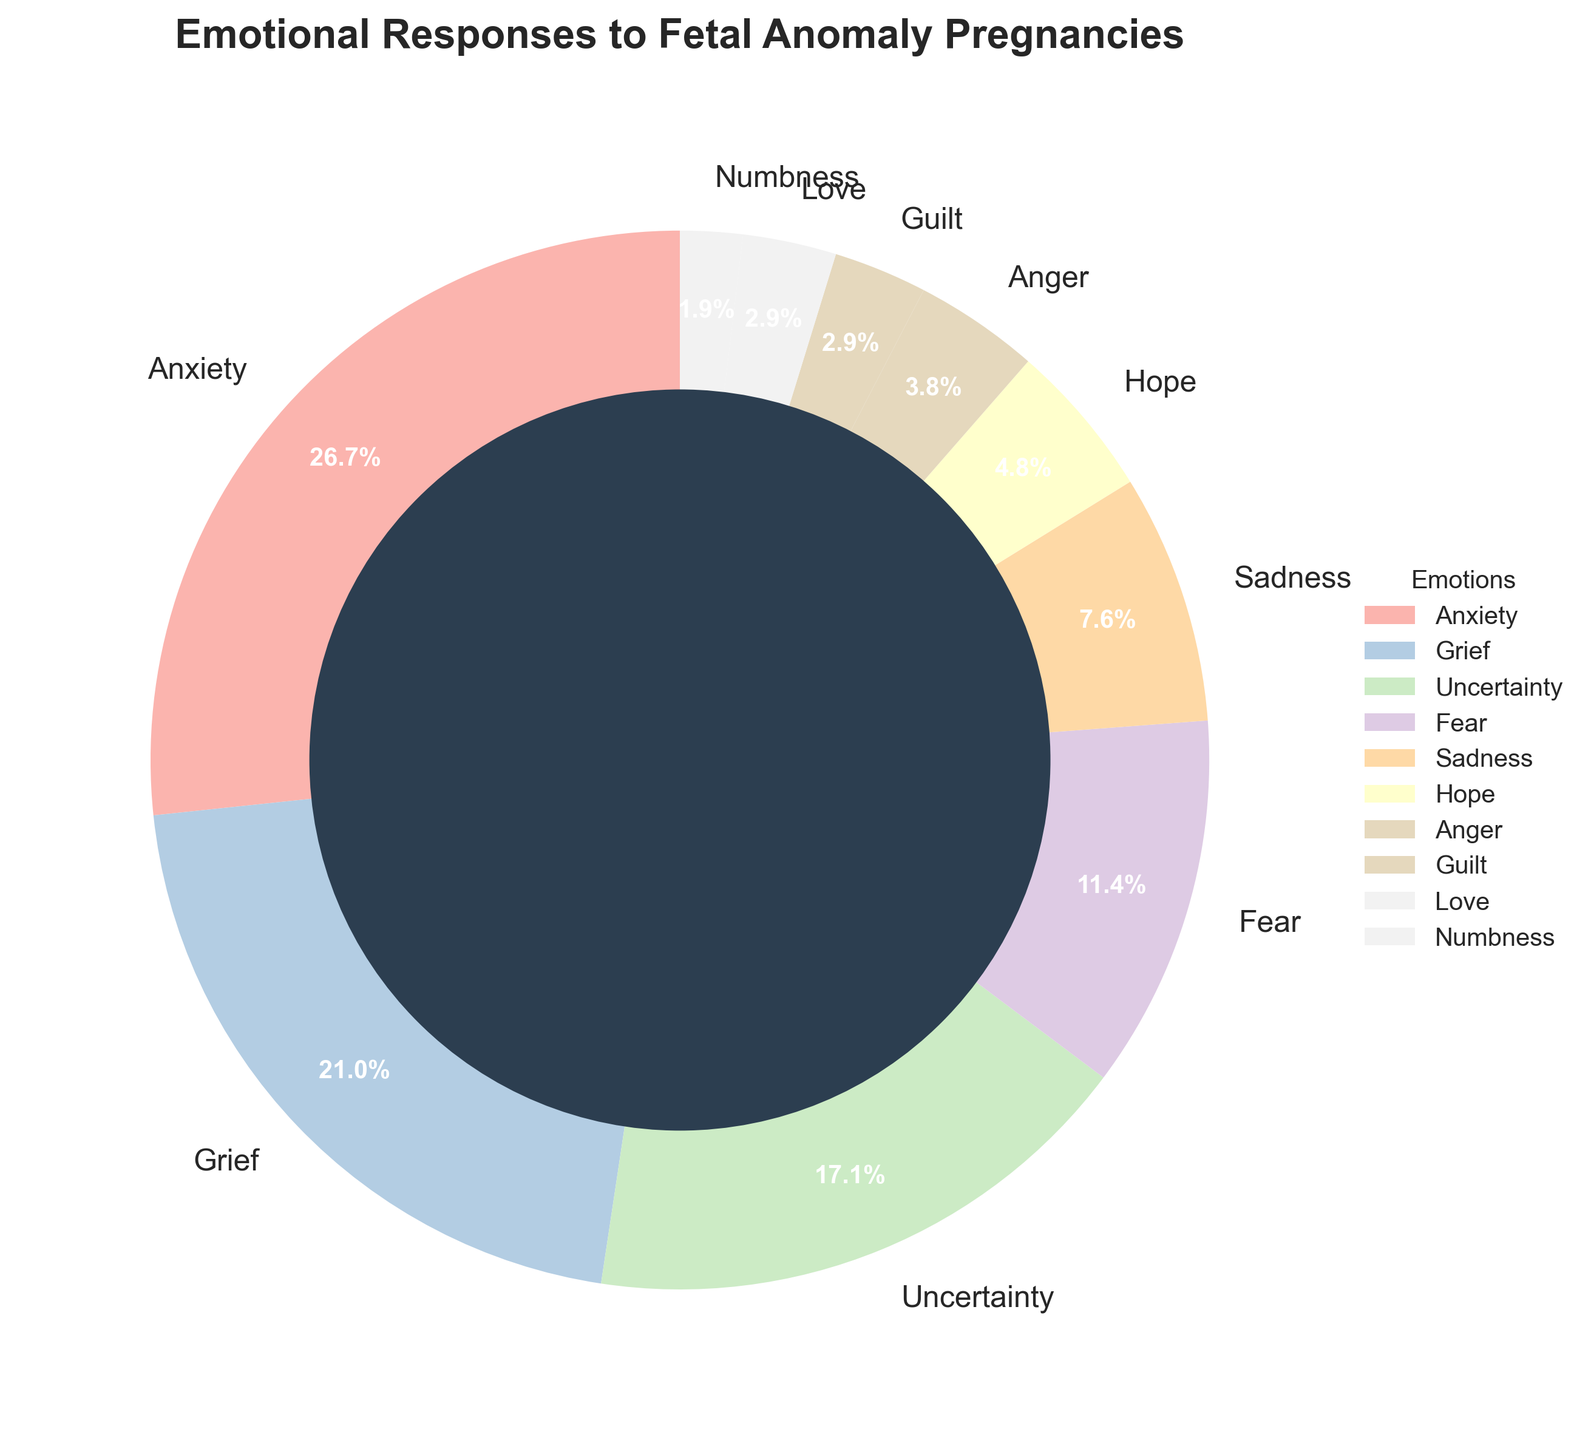What percentage of women reported anxiety? According to the figure, the pie chart segment labeled "Anxiety" shows 28%. Therefore, 28% of women reported anxiety.
Answer: 28% Which emotions combined make up more than half of the responses? Looking at the pie chart, the largest segments are Anxiety (28%), Grief (22%), and Uncertainty (18%). Adding these percentages together: 28% + 22% + 18% = 68%. This sum is more than half.
Answer: Anxiety, Grief, and Uncertainty What’s the difference in percentage between women reporting grief and uncertainty? According to the chart, the percentage for Grief is 22% and for Uncertainty is 18%. The difference is calculated as 22% - 18% = 4%.
Answer: 4% Which emotion is represented in the smallest segment? By looking at the pie chart, the smallest segment corresponds to "Numbness" which is reported at 2%.
Answer: Numbness What is the total percentage of women experiencing sadness, hope, anger, guilt, love, and numbness? Add the percentages for these emotions: Sadness (8%), Hope (5%), Anger (4%), Guilt (3%), Love (3%), and Numbness (2%). 8% + 5% + 4% + 3% + 3% + 2% = 25%.
Answer: 25% Which emotion is more commonly reported: anger or guilt? Refer to the pie chart where the segment for Anger is 4% and the segment for Guilt is 3%. Since 4% is greater than 3%, Anger is more commonly reported than Guilt.
Answer: Anger What is the average percentage of emotions reported if you exclude "Numbness"? Exclude "Numbness" and sum the remaining percentages: 28% + 22% + 18% + 12% + 8% + 5% + 4% + 3% + 3%. The total is 103%. Divide this by the number of remaining emotions (9): 103% / 9 ≈ 11.44%.
Answer: 11.44% Which emotion reported at 5%? According to the pie chart, the emotion labeled "Hope" has a reported percentage of 5%.
Answer: Hope 